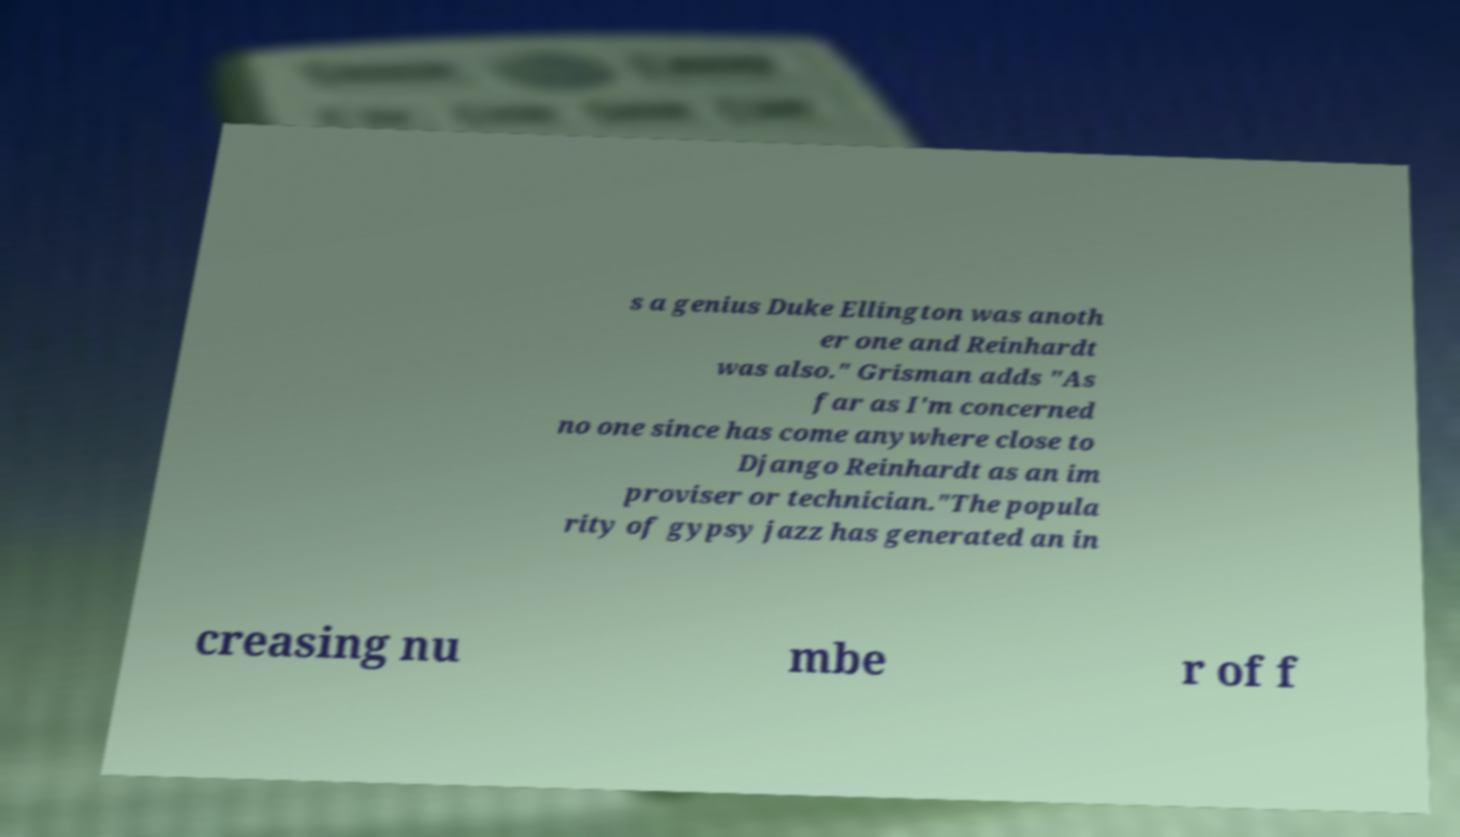Could you extract and type out the text from this image? s a genius Duke Ellington was anoth er one and Reinhardt was also." Grisman adds "As far as I'm concerned no one since has come anywhere close to Django Reinhardt as an im proviser or technician."The popula rity of gypsy jazz has generated an in creasing nu mbe r of f 